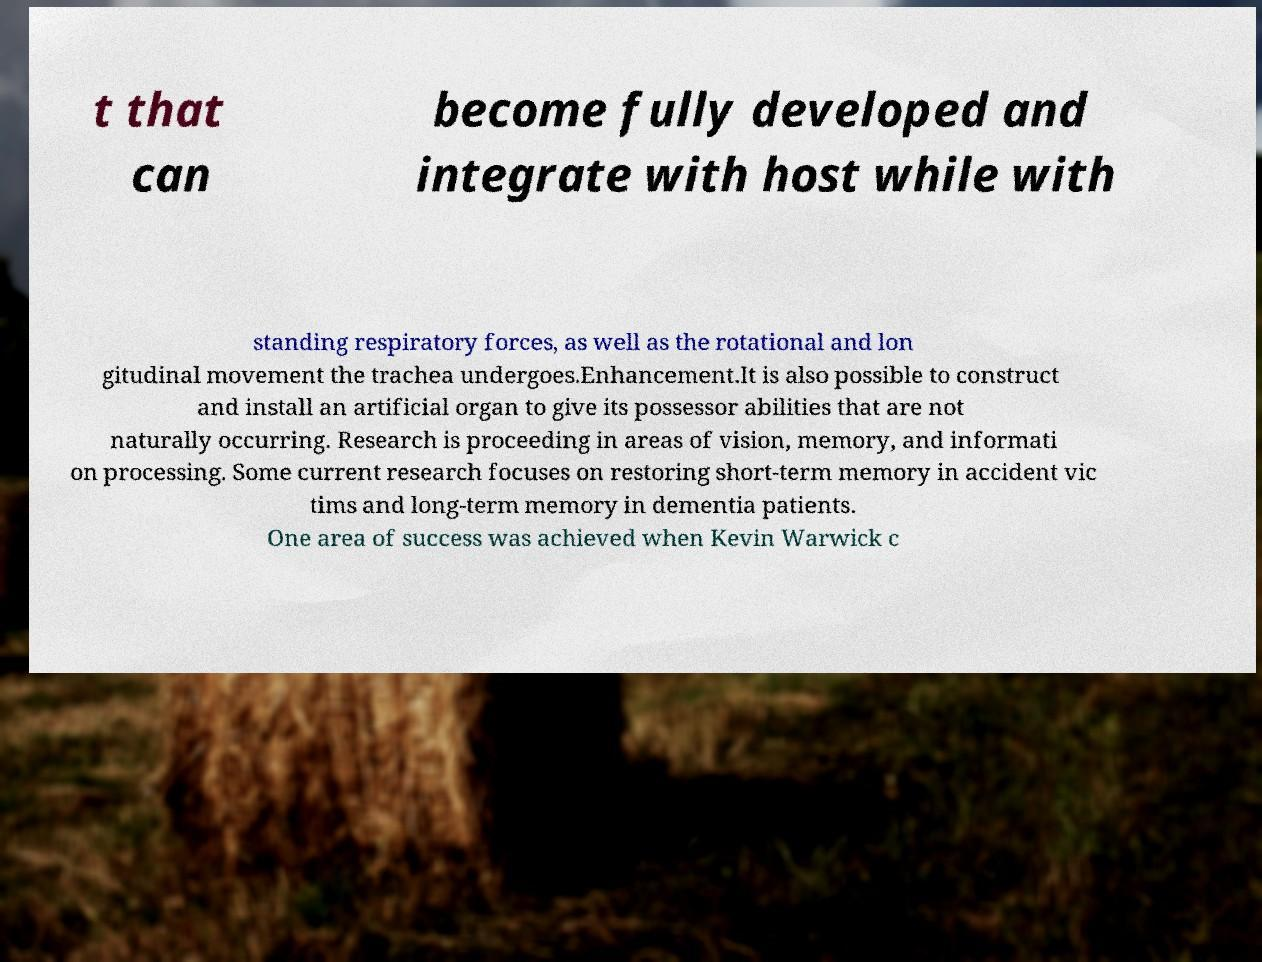Can you accurately transcribe the text from the provided image for me? t that can become fully developed and integrate with host while with standing respiratory forces, as well as the rotational and lon gitudinal movement the trachea undergoes.Enhancement.It is also possible to construct and install an artificial organ to give its possessor abilities that are not naturally occurring. Research is proceeding in areas of vision, memory, and informati on processing. Some current research focuses on restoring short-term memory in accident vic tims and long-term memory in dementia patients. One area of success was achieved when Kevin Warwick c 